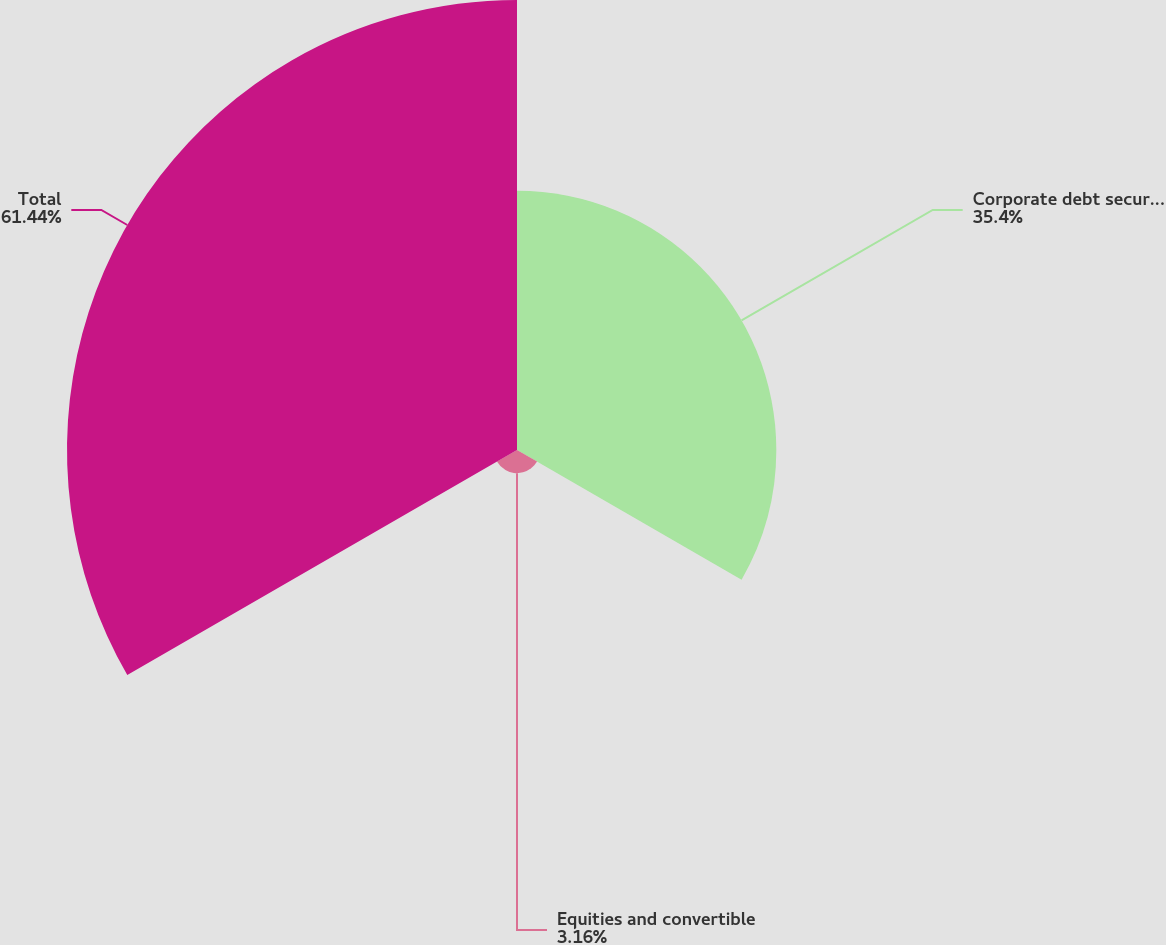Convert chart. <chart><loc_0><loc_0><loc_500><loc_500><pie_chart><fcel>Corporate debt securities<fcel>Equities and convertible<fcel>Total<nl><fcel>35.4%<fcel>3.16%<fcel>61.43%<nl></chart> 